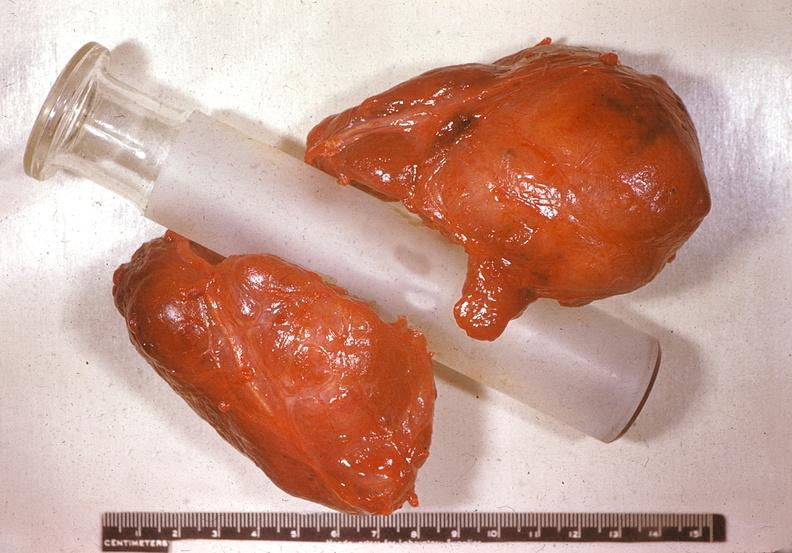what is present?
Answer the question using a single word or phrase. Endocrine 